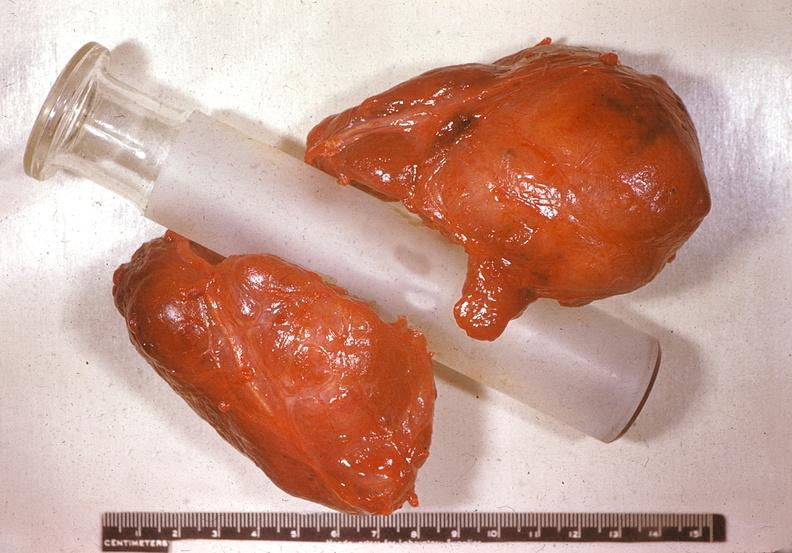what is present?
Answer the question using a single word or phrase. Endocrine 